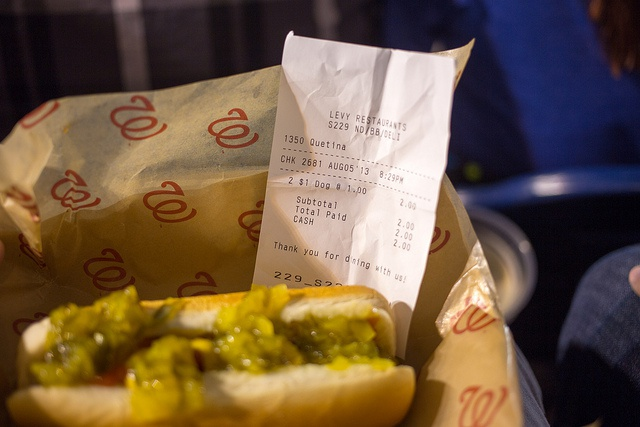Describe the objects in this image and their specific colors. I can see hot dog in black, olive, and tan tones and cup in black, gray, and tan tones in this image. 